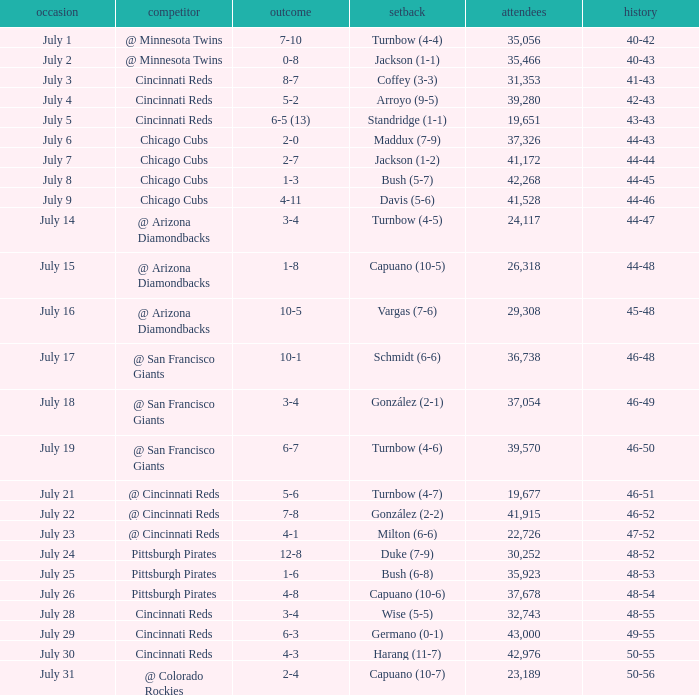What was the loss of the Brewers game when the record was 46-48? Schmidt (6-6). Can you parse all the data within this table? {'header': ['occasion', 'competitor', 'outcome', 'setback', 'attendees', 'history'], 'rows': [['July 1', '@ Minnesota Twins', '7-10', 'Turnbow (4-4)', '35,056', '40-42'], ['July 2', '@ Minnesota Twins', '0-8', 'Jackson (1-1)', '35,466', '40-43'], ['July 3', 'Cincinnati Reds', '8-7', 'Coffey (3-3)', '31,353', '41-43'], ['July 4', 'Cincinnati Reds', '5-2', 'Arroyo (9-5)', '39,280', '42-43'], ['July 5', 'Cincinnati Reds', '6-5 (13)', 'Standridge (1-1)', '19,651', '43-43'], ['July 6', 'Chicago Cubs', '2-0', 'Maddux (7-9)', '37,326', '44-43'], ['July 7', 'Chicago Cubs', '2-7', 'Jackson (1-2)', '41,172', '44-44'], ['July 8', 'Chicago Cubs', '1-3', 'Bush (5-7)', '42,268', '44-45'], ['July 9', 'Chicago Cubs', '4-11', 'Davis (5-6)', '41,528', '44-46'], ['July 14', '@ Arizona Diamondbacks', '3-4', 'Turnbow (4-5)', '24,117', '44-47'], ['July 15', '@ Arizona Diamondbacks', '1-8', 'Capuano (10-5)', '26,318', '44-48'], ['July 16', '@ Arizona Diamondbacks', '10-5', 'Vargas (7-6)', '29,308', '45-48'], ['July 17', '@ San Francisco Giants', '10-1', 'Schmidt (6-6)', '36,738', '46-48'], ['July 18', '@ San Francisco Giants', '3-4', 'González (2-1)', '37,054', '46-49'], ['July 19', '@ San Francisco Giants', '6-7', 'Turnbow (4-6)', '39,570', '46-50'], ['July 21', '@ Cincinnati Reds', '5-6', 'Turnbow (4-7)', '19,677', '46-51'], ['July 22', '@ Cincinnati Reds', '7-8', 'González (2-2)', '41,915', '46-52'], ['July 23', '@ Cincinnati Reds', '4-1', 'Milton (6-6)', '22,726', '47-52'], ['July 24', 'Pittsburgh Pirates', '12-8', 'Duke (7-9)', '30,252', '48-52'], ['July 25', 'Pittsburgh Pirates', '1-6', 'Bush (6-8)', '35,923', '48-53'], ['July 26', 'Pittsburgh Pirates', '4-8', 'Capuano (10-6)', '37,678', '48-54'], ['July 28', 'Cincinnati Reds', '3-4', 'Wise (5-5)', '32,743', '48-55'], ['July 29', 'Cincinnati Reds', '6-3', 'Germano (0-1)', '43,000', '49-55'], ['July 30', 'Cincinnati Reds', '4-3', 'Harang (11-7)', '42,976', '50-55'], ['July 31', '@ Colorado Rockies', '2-4', 'Capuano (10-7)', '23,189', '50-56']]} 